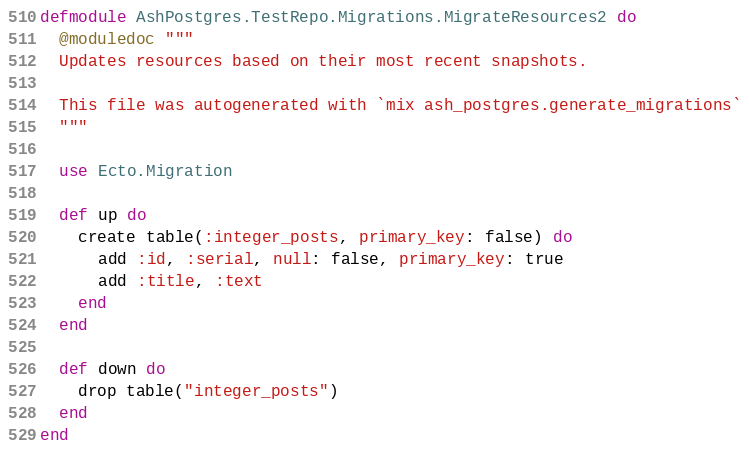Convert code to text. <code><loc_0><loc_0><loc_500><loc_500><_Elixir_>defmodule AshPostgres.TestRepo.Migrations.MigrateResources2 do
  @moduledoc """
  Updates resources based on their most recent snapshots.

  This file was autogenerated with `mix ash_postgres.generate_migrations`
  """

  use Ecto.Migration

  def up do
    create table(:integer_posts, primary_key: false) do
      add :id, :serial, null: false, primary_key: true
      add :title, :text
    end
  end

  def down do
    drop table("integer_posts")
  end
end</code> 